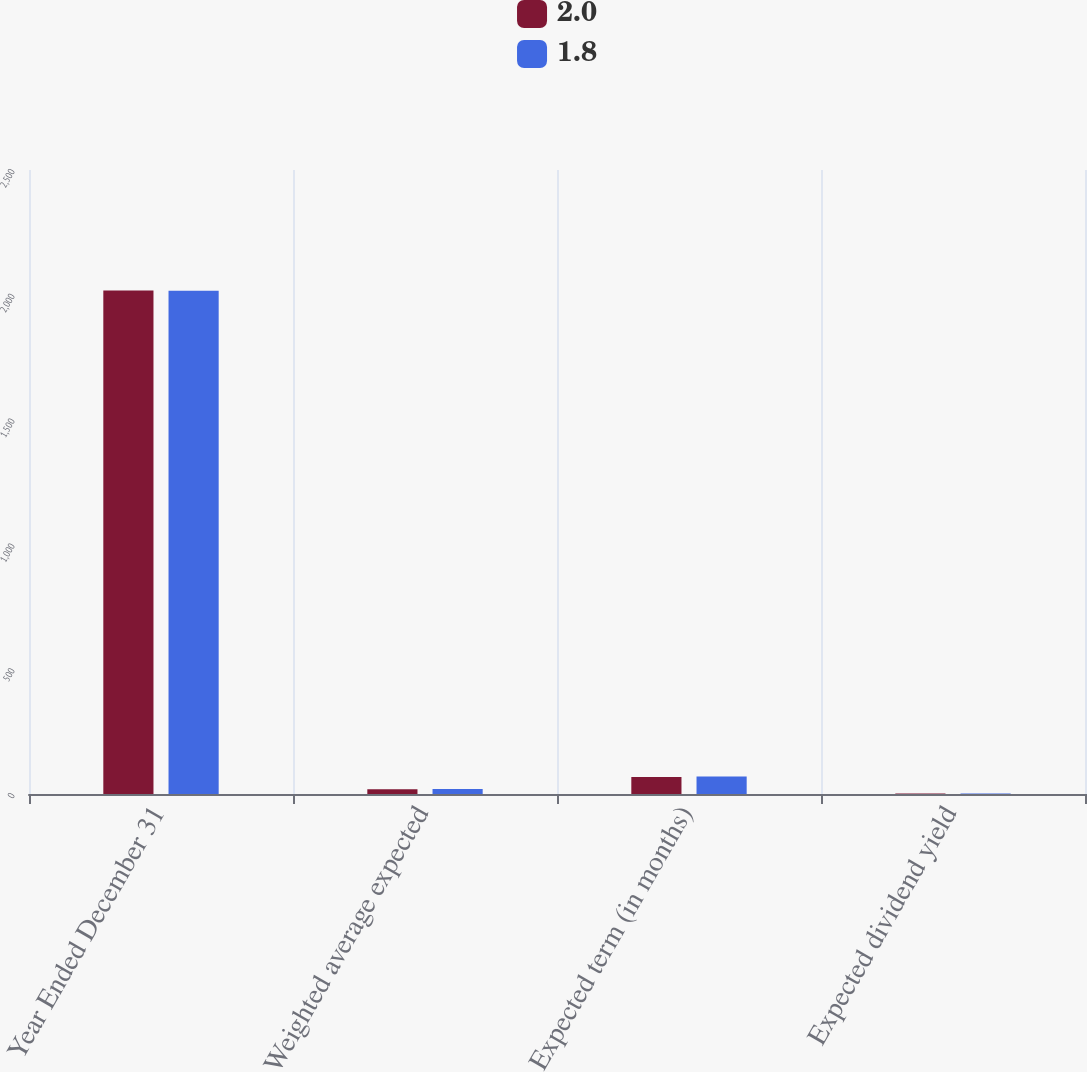<chart> <loc_0><loc_0><loc_500><loc_500><stacked_bar_chart><ecel><fcel>Year Ended December 31<fcel>Weighted average expected<fcel>Expected term (in months)<fcel>Expected dividend yield<nl><fcel>2<fcel>2017<fcel>19.4<fcel>68<fcel>1.8<nl><fcel>1.8<fcel>2016<fcel>20<fcel>70<fcel>2<nl></chart> 